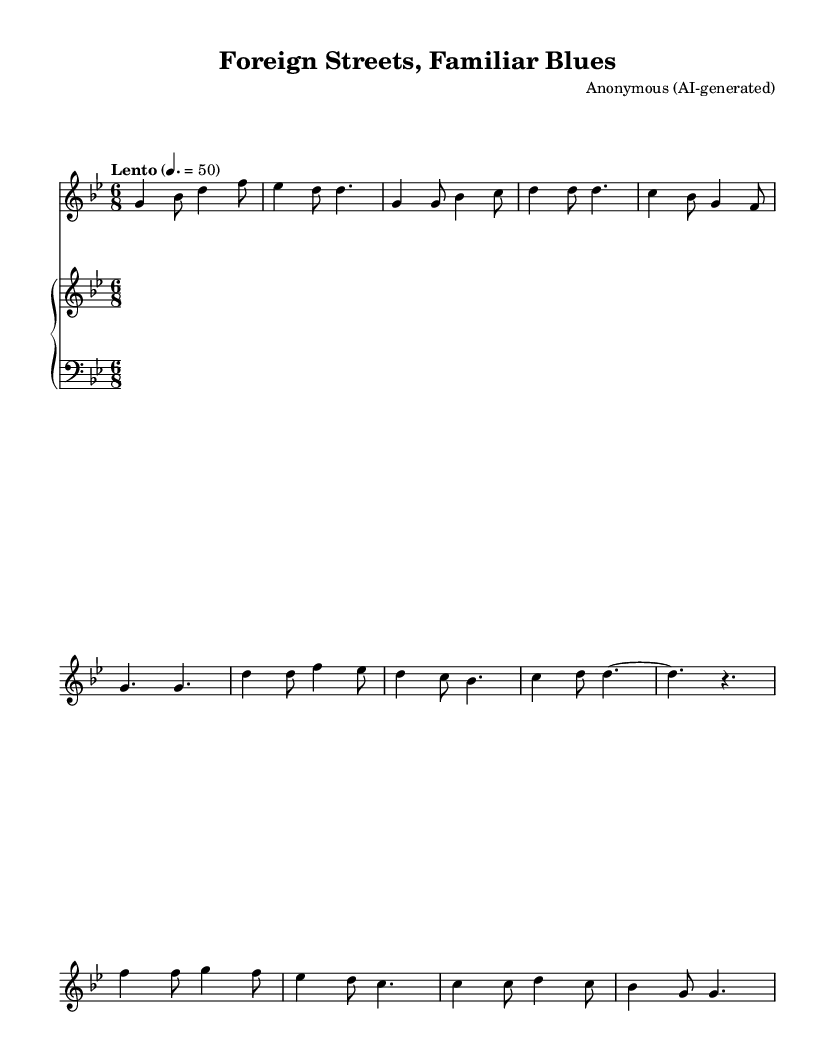What is the key signature of this music? The key signature shows two flats, indicating G minor.
Answer: G minor What is the time signature of this music? The time signature is indicated at the beginning of the piece as 6/8, meaning there are six eighth notes in each measure.
Answer: 6/8 What is the tempo of this piece? The tempo marking says "Lento" with a metronome marking of 50, meaning it should be played slowly at 50 beats per minute.
Answer: 50 How many measures are in the provided excerpt? Counting the measures in the soprano part, there are a total of 8 measures shown in the excerpt.
Answer: 8 What is the primary mood conveyed in the music? The piece is a soulful blues ballad, which typically conveys a sense of longing and reflection, as suggested by the style and tempo.
Answer: Soulful What is the predominant melodic shape in the first verse? The melody in the first verse primarily moves stepwise with occasional leaps, creating a flowing contour typical in blues music.
Answer: Stepwise What type of harmony supports the melody in this excerpt? The harmony consists of simple triadic chords that support the melodic line, characteristic of blues styles that rely on diatonic harmonies.
Answer: Triadic 